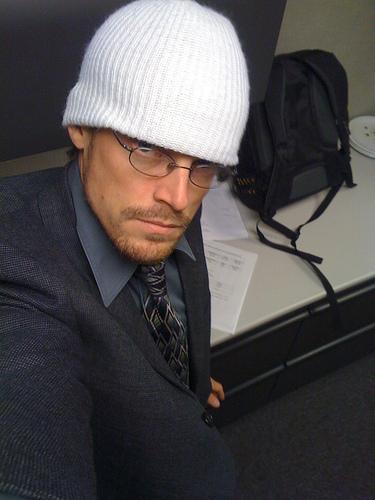What is on the guy's head?
Give a very brief answer. Hat. What location are the people at?
Keep it brief. Inside. Is he likely to get mugged if he walked down a dark alleyway like this?
Write a very short answer. Yes. What is on his hat?
Keep it brief. Nothing. Is the man wearing glasses?
Quick response, please. Yes. What does his hat say?
Be succinct. Nothing. What style of hat is he wearing?
Be succinct. Beanie. Is the man on the John?
Be succinct. No. How old is the man?
Keep it brief. 30. Is the man using the computer?
Be succinct. No. Is the hat blue?
Answer briefly. No. What color is his hat?
Short answer required. White. 